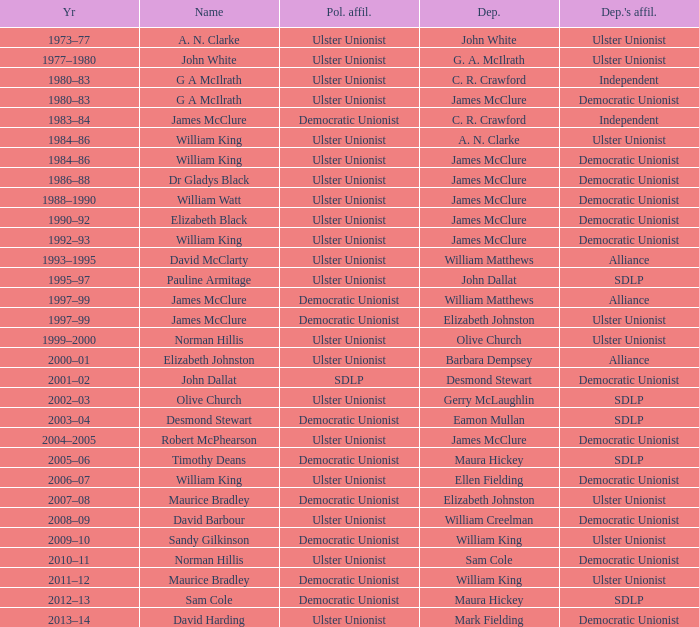What is the name of the Deputy when the Name was elizabeth black? James McClure. 